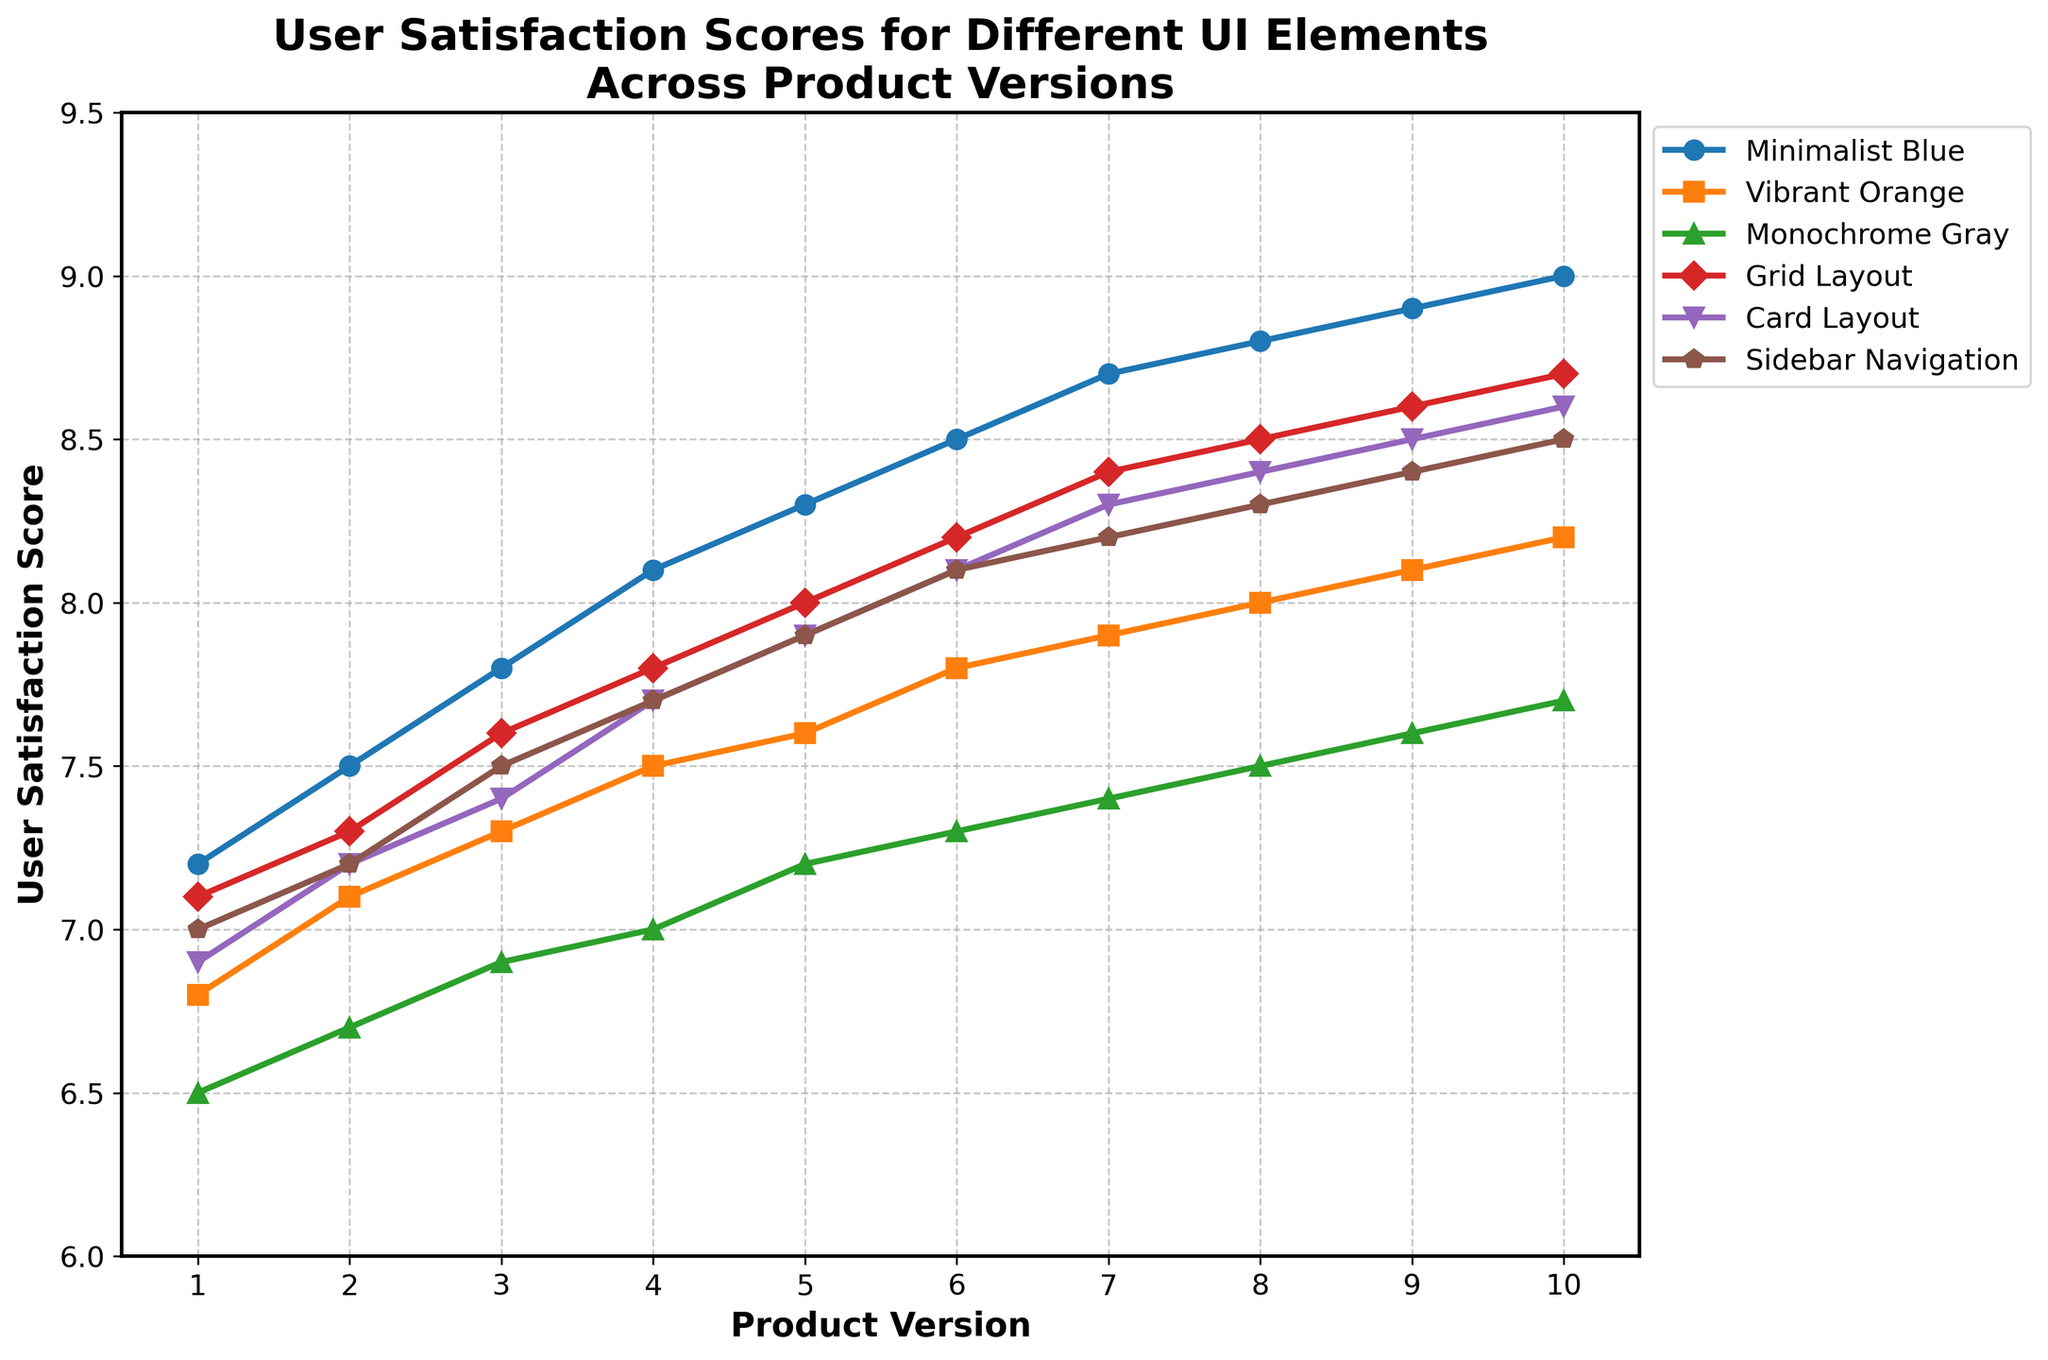What version shows the highest user satisfaction for the Minimalist Blue scheme? In the figure, locate the line corresponding to Minimalist Blue. Identify the highest point on this line and note the corresponding product version on the x-axis. The highest point on the Minimalist Blue line is at Version 10.0.
Answer: Version 10.0 How does user satisfaction for the Card Layout in Version 5.0 compare to the Sidebar Navigation in the same version? Locate user satisfaction scores for both Card Layout and Sidebar Navigation in Version 5.0 on the figure. Compare the values. The score for Card Layout is 7.9, and for Sidebar Navigation, it is 7.9 as well. Both have the same score.
Answer: Equal Which UI element has the most consistent increase in user satisfaction over all product versions? Observe the trend lines of each UI element. The Minimalist Blue line shows a steady and consistent increase across all versions, with no dips or inconsistencies.
Answer: Minimalist Blue What is the difference in user satisfaction between the Grid Layout in Version 4.0 and the Vibrant Orange scheme in Version 4.0? Find user satisfaction scores for both the Grid Layout and Vibrant Orange scheme at Version 4.0. Subtract the Vibrant Orange score (7.5) from the Grid Layout score (7.8). The difference is 0.3.
Answer: 0.3 What is the average user satisfaction score for Monochrome Gray from Versions 1.0 to 5.0? Find user satisfaction scores for Monochrome Gray from Versions 1.0 to 5.0: 6.5, 6.7, 6.9, 7.0, and 7.2. Sum these scores (6.5 + 6.7 + 6.9 + 7.0 + 7.2 = 34.3), then divide by the number of versions (34.3/5). The average score is 6.86.
Answer: 6.86 Which two UI elements show the most significant improvement from Version 1.0 to Version 10.0? Compare the user satisfaction scores for each UI element at Version 1.0 and Version 10.0. Calculate the difference for each element. Minimalist Blue improves from 7.2 to 9.0 (difference of 1.8) and Grid Layout from 7.1 to 8.7 (difference of 1.6). These two show the most improvement.
Answer: Minimalist Blue and Grid Layout Between Versions 3.0 and 6.0, which UI element has the least variance in user satisfaction scores? Check the differences in user satisfaction scores for each UI element between Versions 3.0 and 6.0. Minimalist Blue ranges from 7.8 to 8.5 (variance of 0.7), Vibrant Orange from 7.3 to 7.8 (variance of 0.5), and so on. Monochrome Gray has scores of 6.9 and 7.3, giving it a variance of 0.4, which is the least.
Answer: Monochrome Gray 